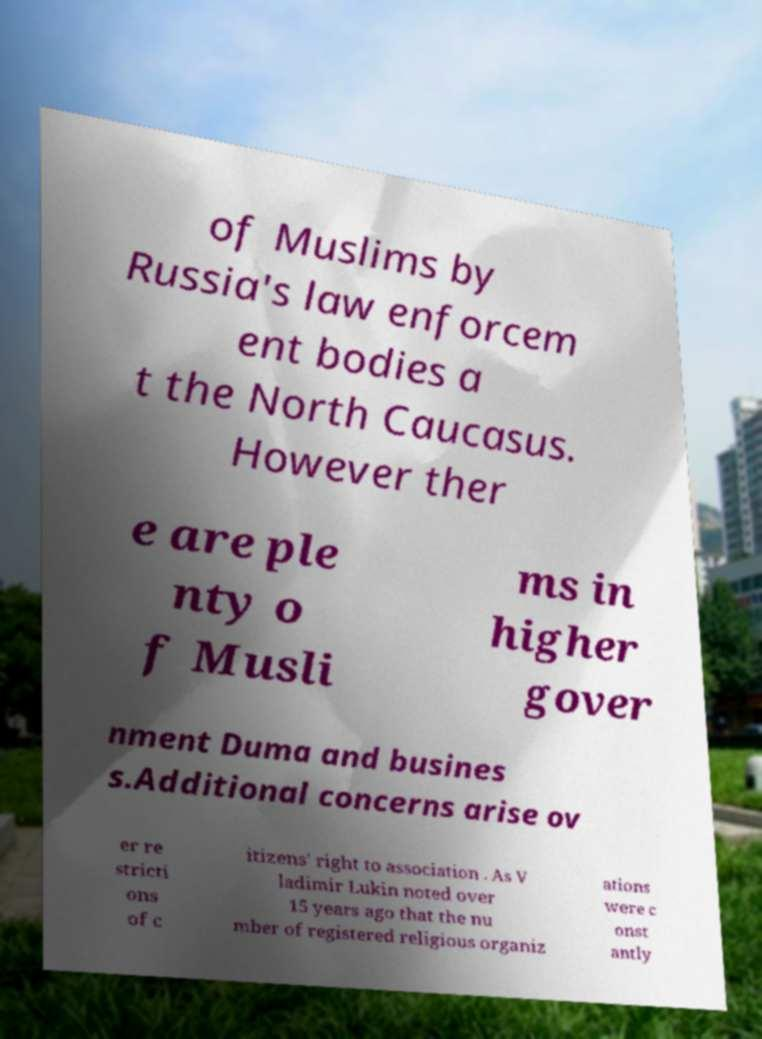Please read and relay the text visible in this image. What does it say? of Muslims by Russia's law enforcem ent bodies a t the North Caucasus. However ther e are ple nty o f Musli ms in higher gover nment Duma and busines s.Additional concerns arise ov er re stricti ons of c itizens' right to association . As V ladimir Lukin noted over 15 years ago that the nu mber of registered religious organiz ations were c onst antly 